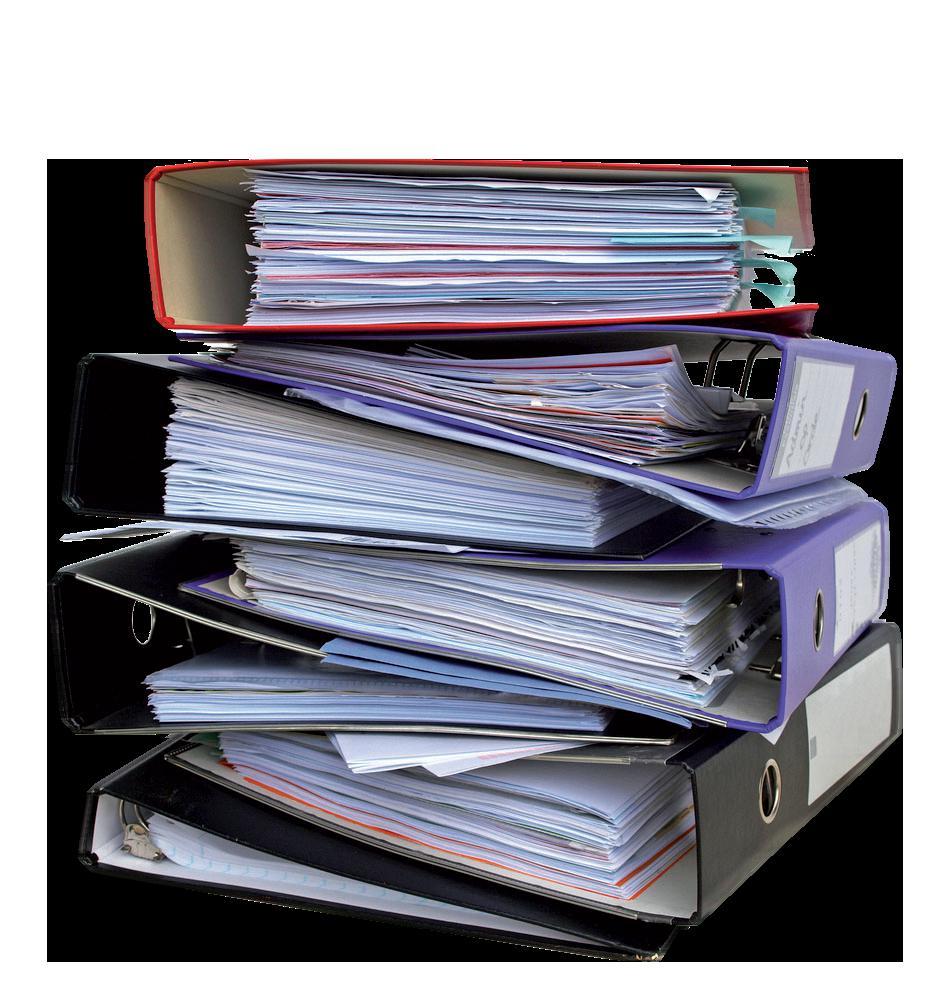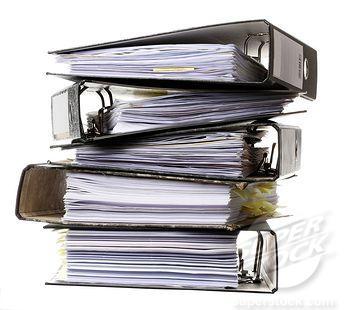The first image is the image on the left, the second image is the image on the right. Given the left and right images, does the statement "At least one image shows binders stacked alternately front-to-back, with no more than seven total binders in the image." hold true? Answer yes or no. Yes. 